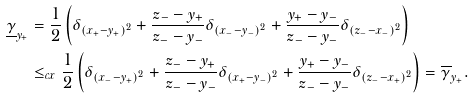<formula> <loc_0><loc_0><loc_500><loc_500>\underline { \gamma } _ { y _ { + } } & = \frac { 1 } { 2 } \left ( \delta _ { ( x _ { + } - y _ { + } ) ^ { 2 } } + \frac { z _ { - } - y _ { + } } { z _ { - } - y _ { - } } \delta _ { ( x _ { - } - y _ { - } ) ^ { 2 } } + \frac { y _ { + } - y _ { - } } { z _ { - } - y _ { - } } \delta _ { ( z _ { - } - x _ { - } ) ^ { 2 } } \right ) \\ & \leq _ { c x } \frac { 1 } { 2 } \left ( \delta _ { ( x _ { - } - y _ { + } ) ^ { 2 } } + \frac { z _ { - } - y _ { + } } { z _ { - } - y _ { - } } \delta _ { ( x _ { + } - y _ { - } ) ^ { 2 } } + \frac { y _ { + } - y _ { - } } { z _ { - } - y _ { - } } \delta _ { ( z _ { - } - x _ { + } ) ^ { 2 } } \right ) = \overline { \gamma } _ { y _ { + } } .</formula> 